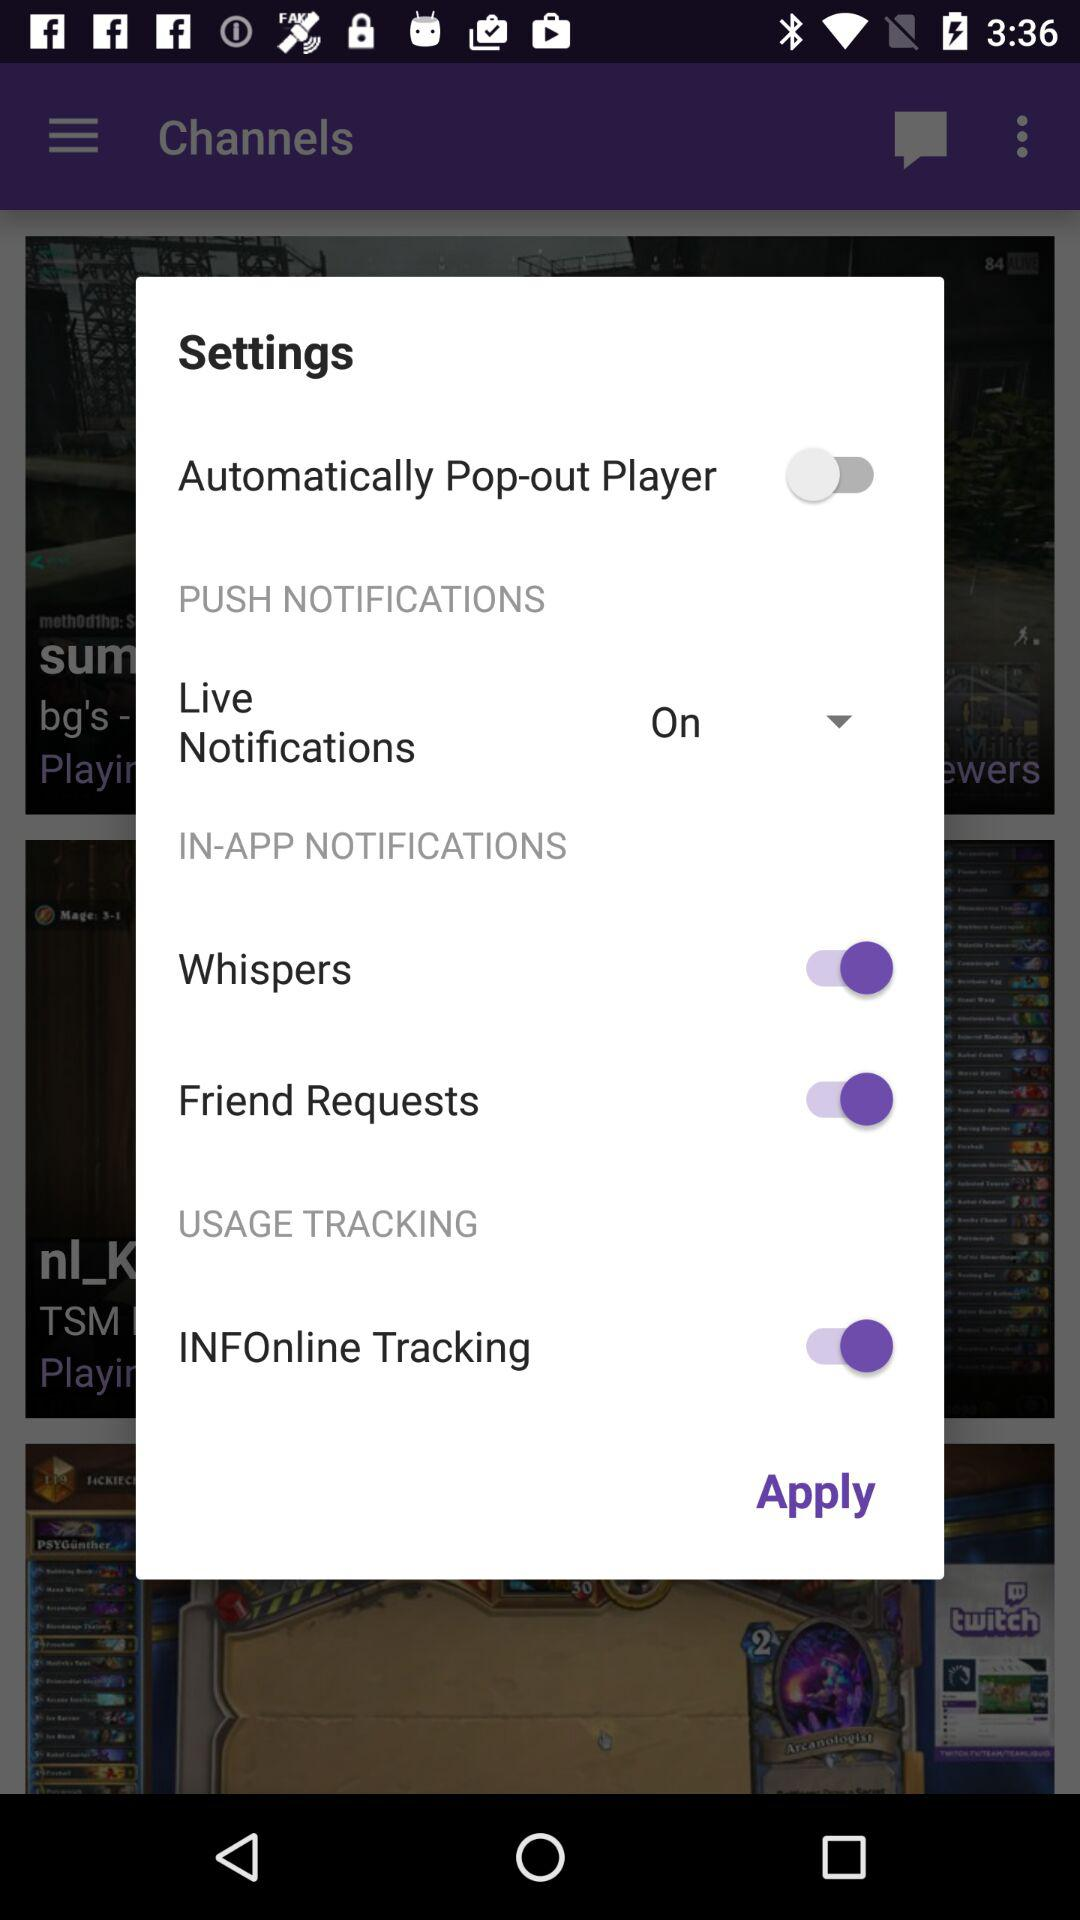Which setting has been enabled? The enabled settings are "Whispers", "Friend Requests", and "INFOnline Tracking". 